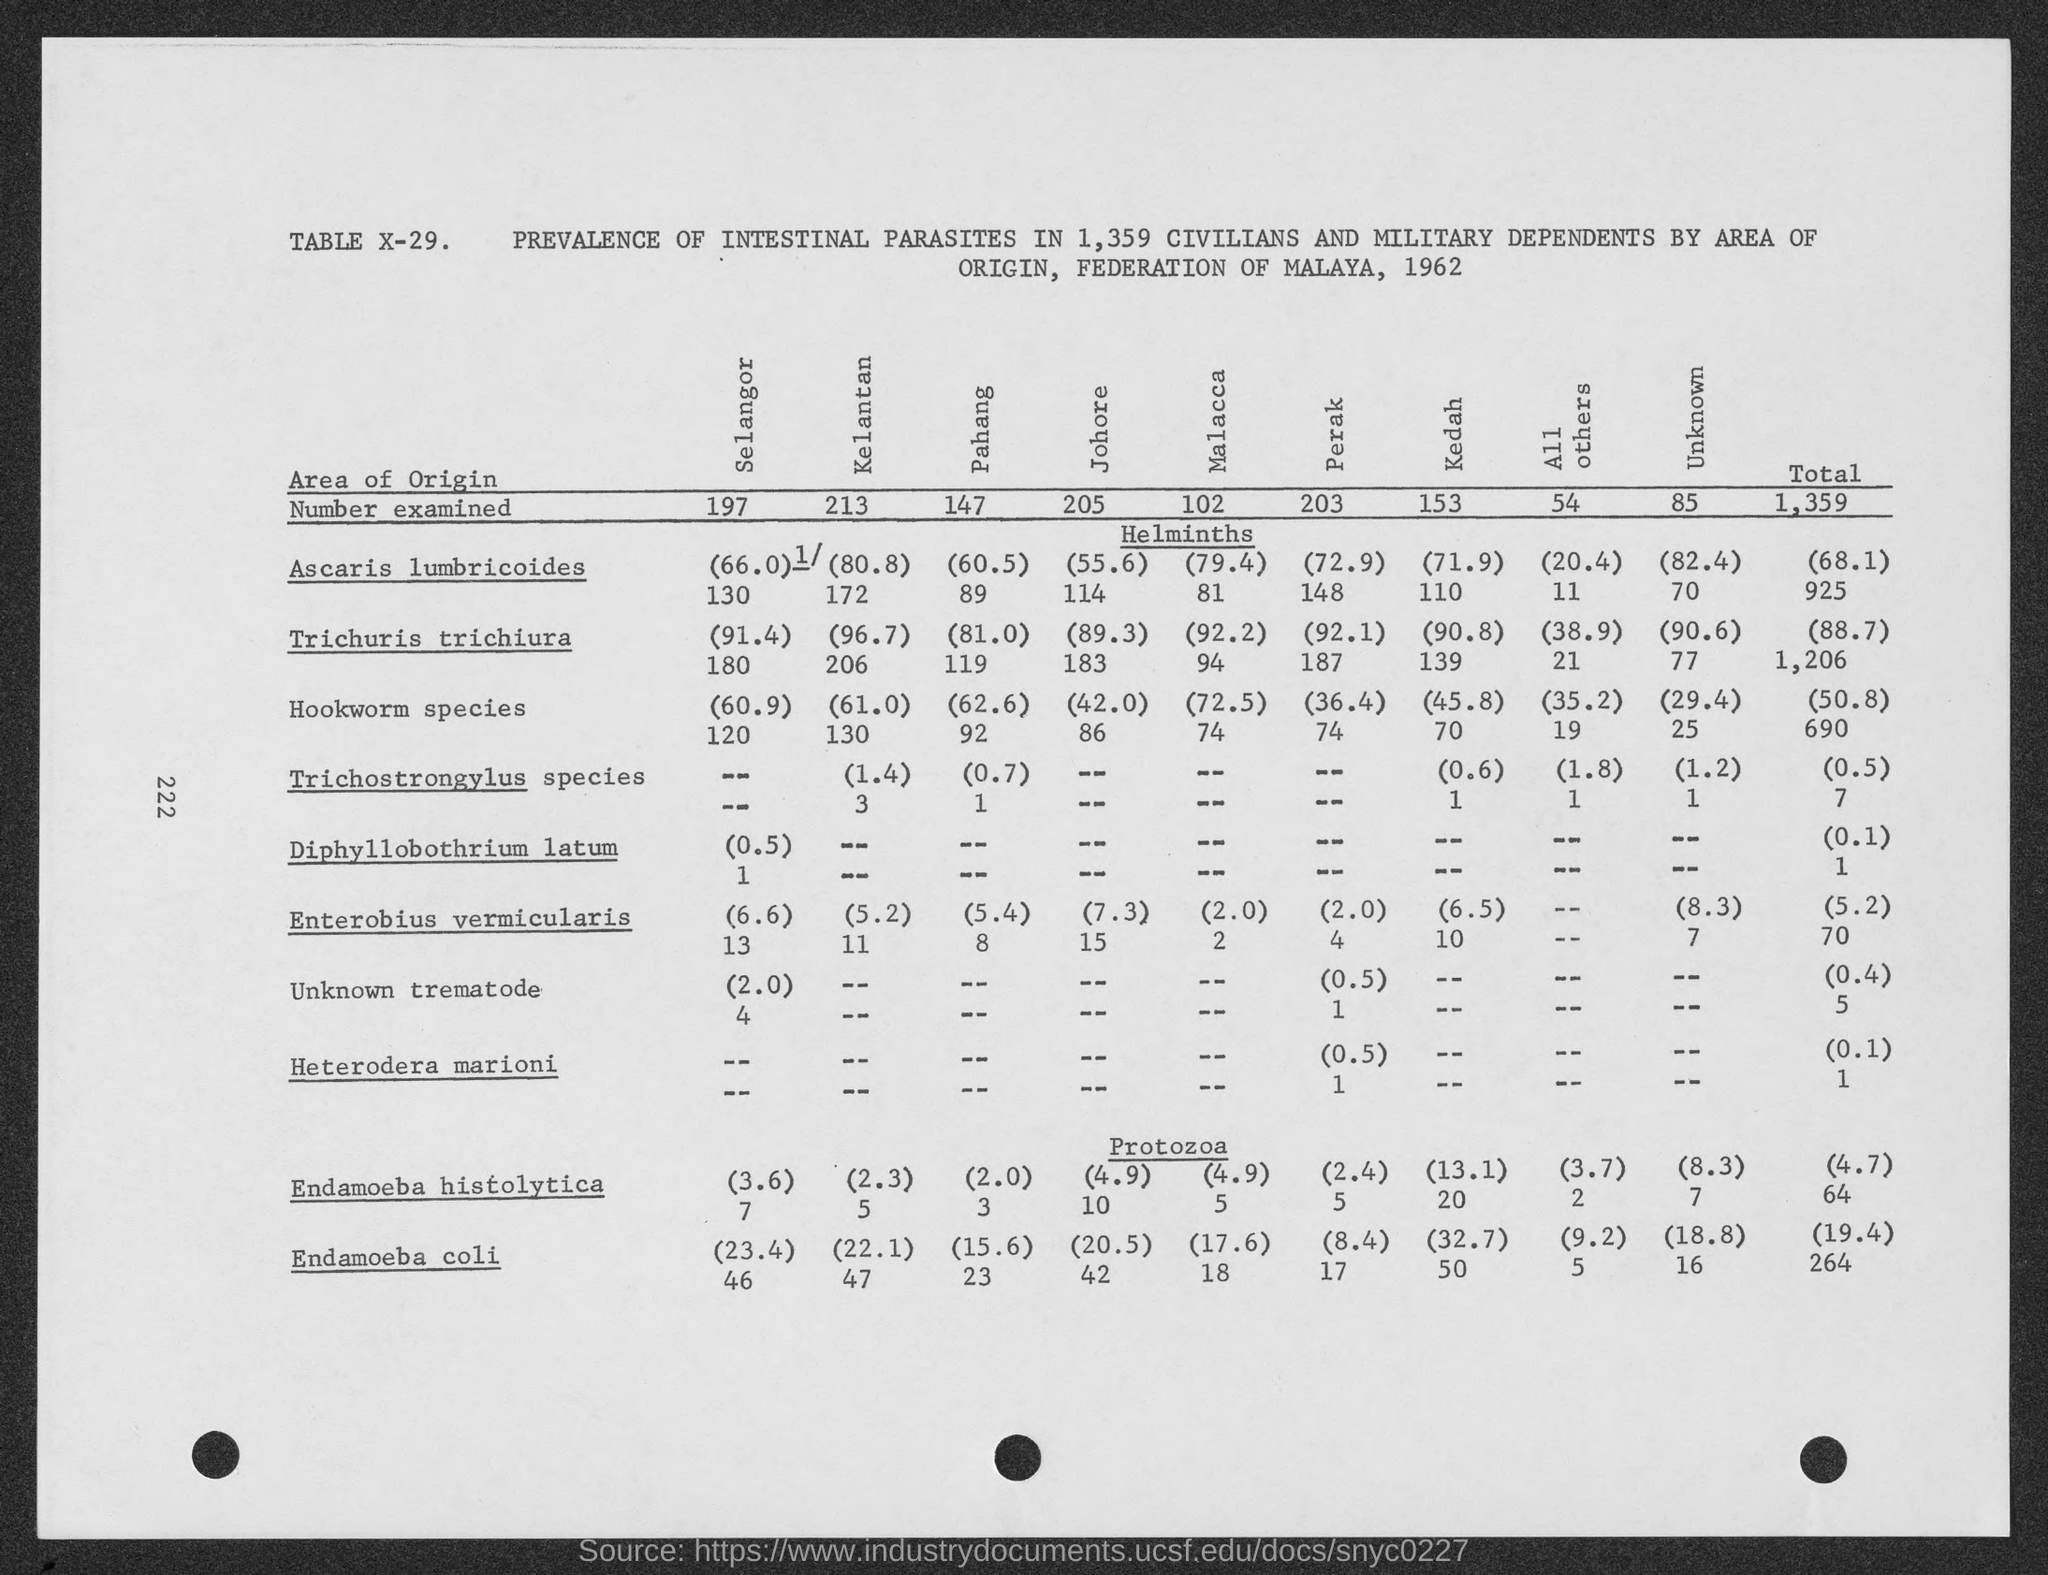List a handful of essential elements in this visual. A total of 1,359 individuals were examined. There were 147 individuals examined in Pahang. The page number is 222 as declared. The table number is x-29. 